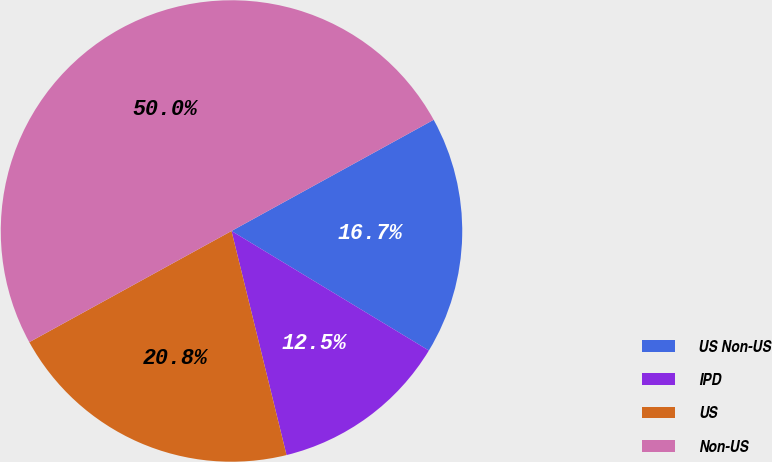Convert chart to OTSL. <chart><loc_0><loc_0><loc_500><loc_500><pie_chart><fcel>US Non-US<fcel>IPD<fcel>US<fcel>Non-US<nl><fcel>16.67%<fcel>12.5%<fcel>20.83%<fcel>50.0%<nl></chart> 